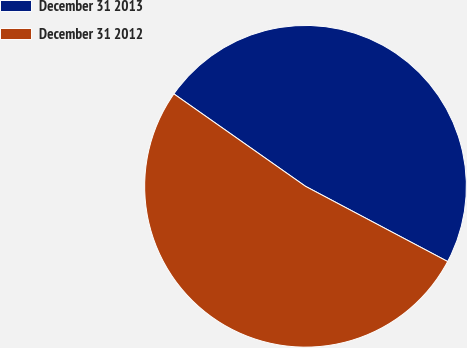Convert chart. <chart><loc_0><loc_0><loc_500><loc_500><pie_chart><fcel>December 31 2013<fcel>December 31 2012<nl><fcel>48.0%<fcel>52.0%<nl></chart> 